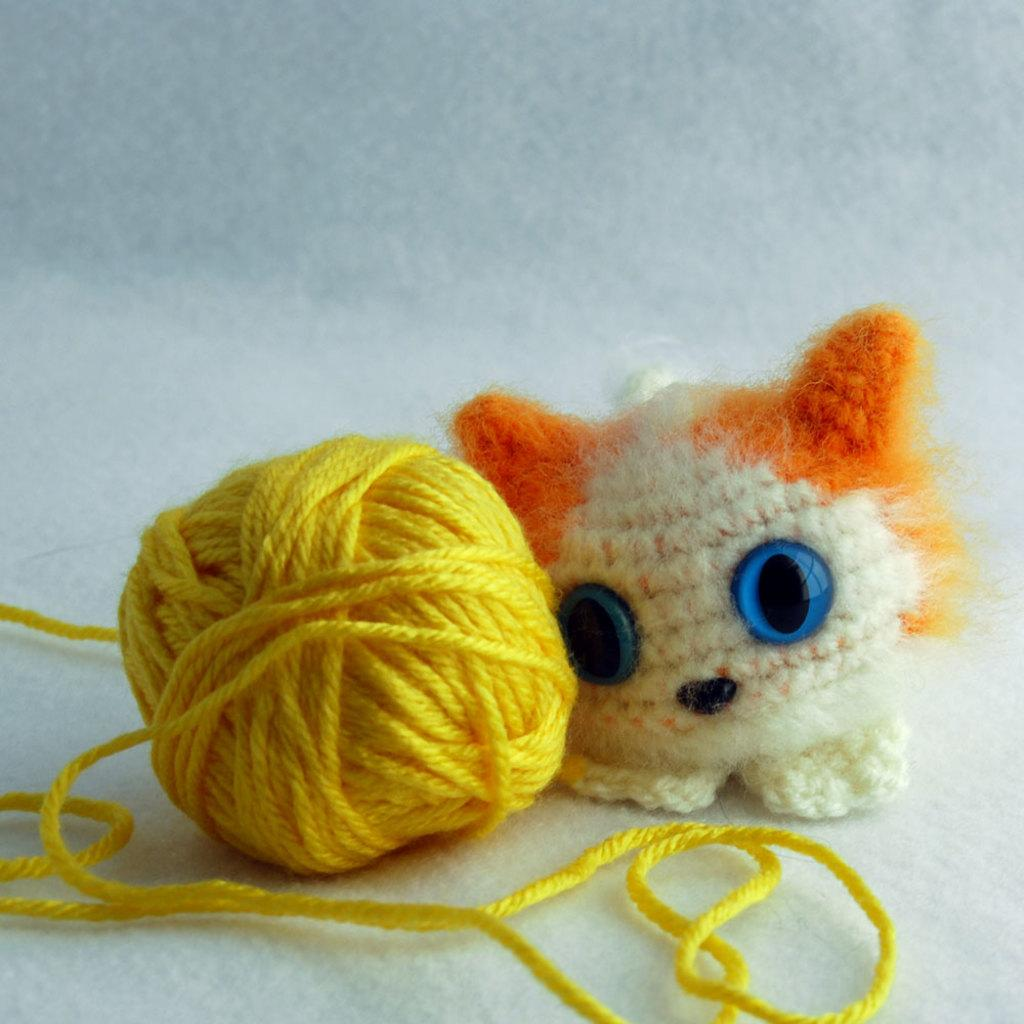What is the main object in the image? There is a yellow color thread roll in the image. What else can be seen on the surface in the image? There is a toy on the surface in the image. What type of organization is responsible for the potato in the image? There is no potato present in the image, so it is not possible to determine which organization might be responsible for it. 